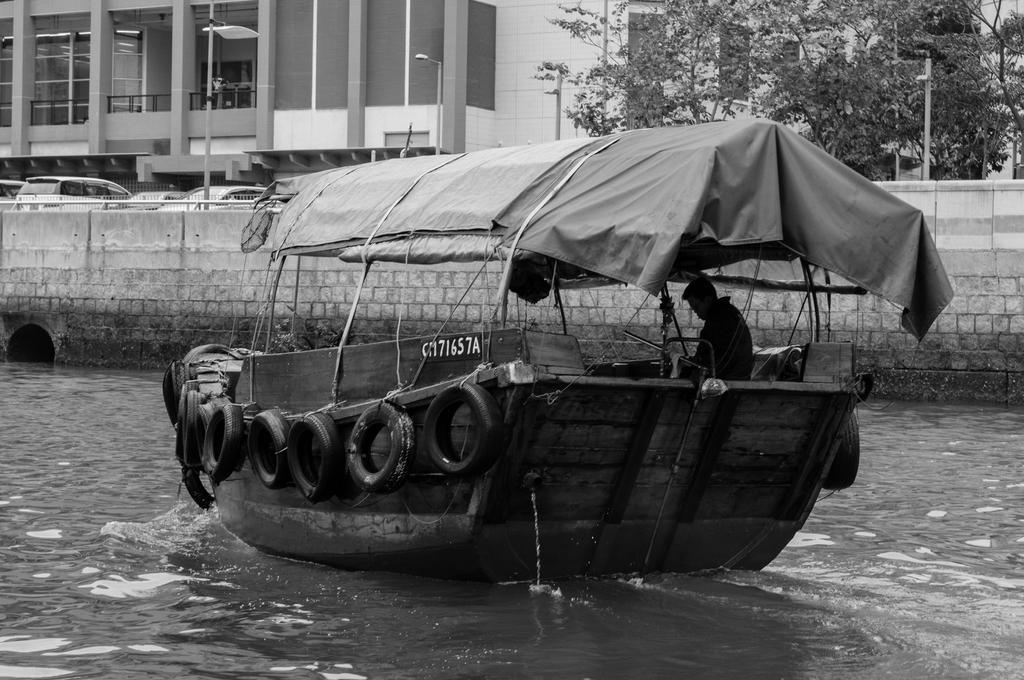Could you give a brief overview of what you see in this image? This is a black and white image. In this image, we can see a person is sailing a boat with tyres on the water. In the background, we can see wall, vehicles, poles, trees, pillars, street lights and glass objects. 